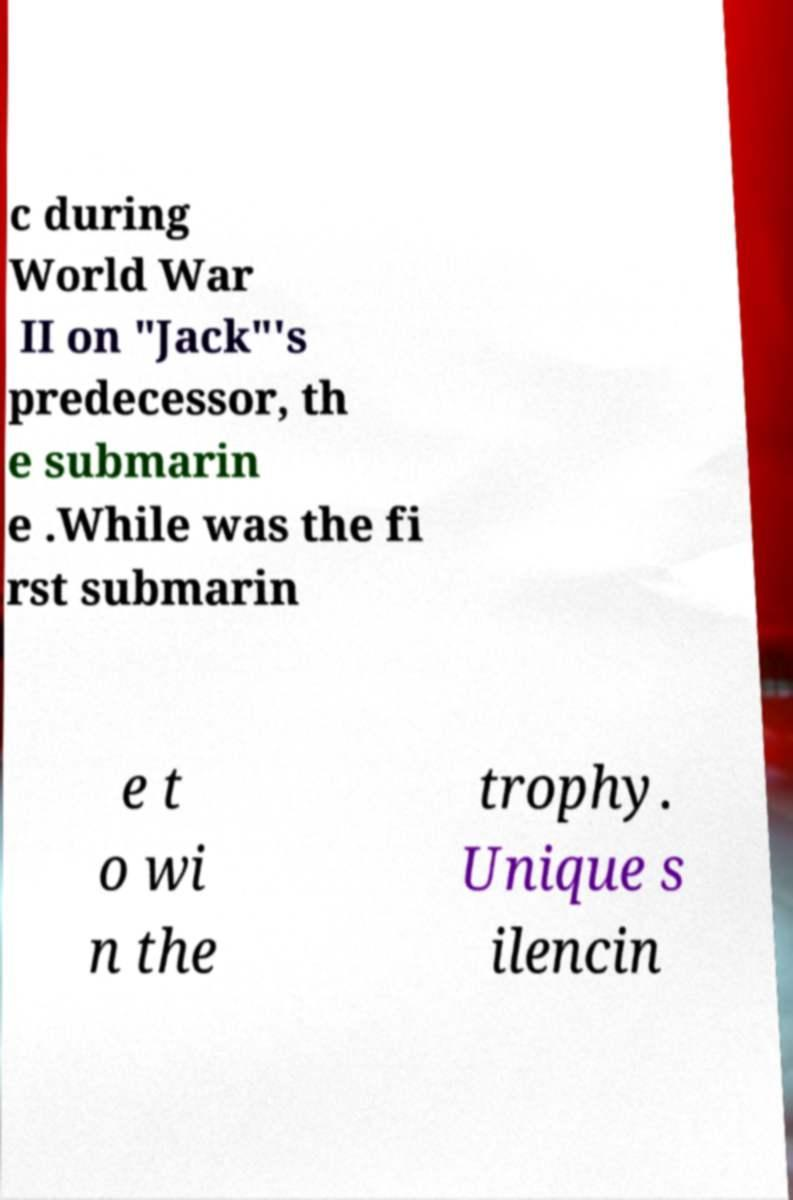Can you accurately transcribe the text from the provided image for me? c during World War II on "Jack"'s predecessor, th e submarin e .While was the fi rst submarin e t o wi n the trophy. Unique s ilencin 